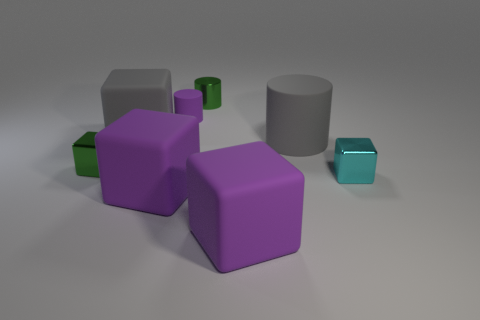Subtract all brown blocks. Subtract all red cylinders. How many blocks are left? 5 Add 1 cylinders. How many objects exist? 9 Subtract all blocks. How many objects are left? 3 Subtract all big purple rubber cubes. Subtract all shiny cylinders. How many objects are left? 5 Add 6 matte cylinders. How many matte cylinders are left? 8 Add 1 tiny purple rubber cubes. How many tiny purple rubber cubes exist? 1 Subtract 0 yellow cubes. How many objects are left? 8 